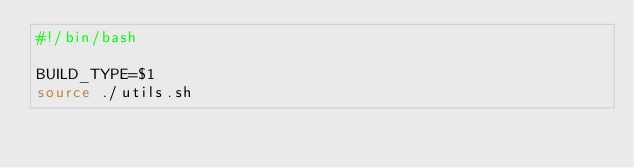Convert code to text. <code><loc_0><loc_0><loc_500><loc_500><_Bash_>#!/bin/bash

BUILD_TYPE=$1
source ./utils.sh</code> 